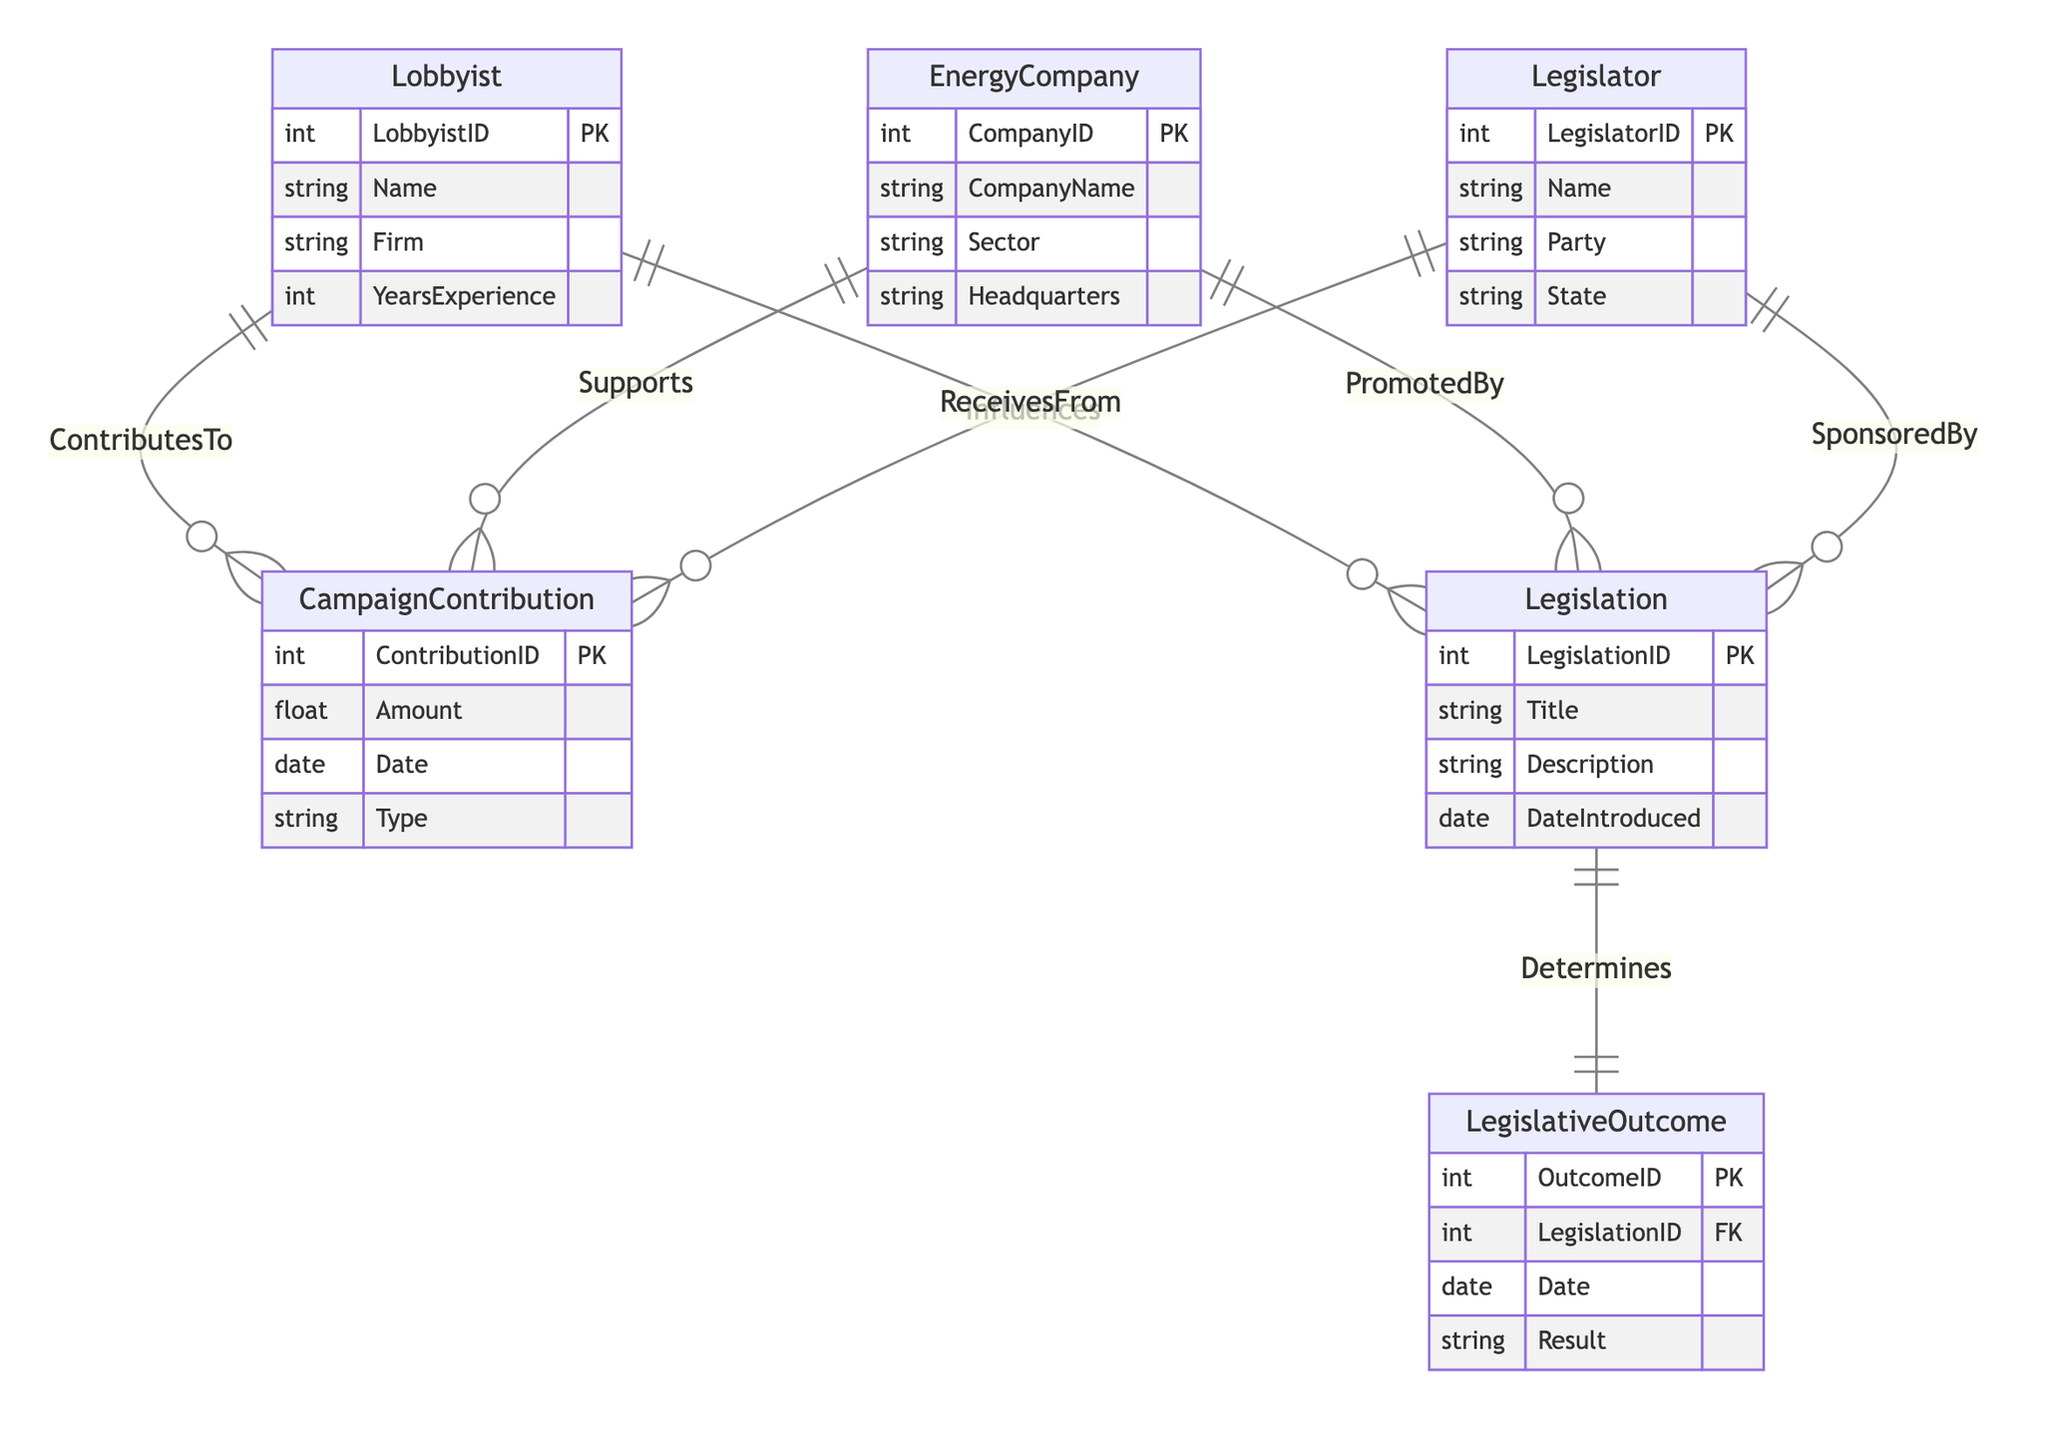What entities are involved in campaign contributions? The diagram shows three entities: Lobbyist, EnergyCompany, and Legislator, which all interact through the CampaignContribution entity. Each of these entities is connected to CampaignContribution either as contributors or receivers.
Answer: Lobbyist, EnergyCompany, Legislator How many attributes does the Legislation entity have? The Legislation entity includes four attributes: LegislationID, Title, Description, and DateIntroduced. Counting these attributes gives us a total of four.
Answer: Four What relationship connects Legislator and Legislation? The diagram shows the relationship "SponsoredBy," connecting Legislator and Legislation. This indicates that legislators sponsor certain pieces of legislation.
Answer: SponsoredBy Which company supports a campaign contribution? The relationship "Supports" connects the EnergyCompany entity to the CampaignContribution entity, indicating that energy companies can support contributions.
Answer: Supports How many entities are involved in determining legislative outcomes? The diagram indicates that there are two entities involved in this process: Legislation and LegislativeOutcome. The relationship "Determines" connects these two entities.
Answer: Two If a Lobbyist influences legislation, what ensures the outcome of that legislation? The relationship "Determines" connects Legislation to LegislativeOutcome, meaning that the legislation influenced by the lobbyist will lead to a certain outcome as defined in the LegislativeOutcome entity. Thus, the outcome is ensured by this relationship.
Answer: Determines Which entity represents the financial aspect of political influence? The CampaignContribution entity embodies the financial contributions made by lobbyists or energy companies to legislators, reflecting the financial aspect of political influence in the diagram.
Answer: CampaignContribution How many relationships are there between the entities? The diagram presents seven distinct relationships between the various entities, which involve contributions, support, sponsorship, influence, and outcome determination.
Answer: Seven 